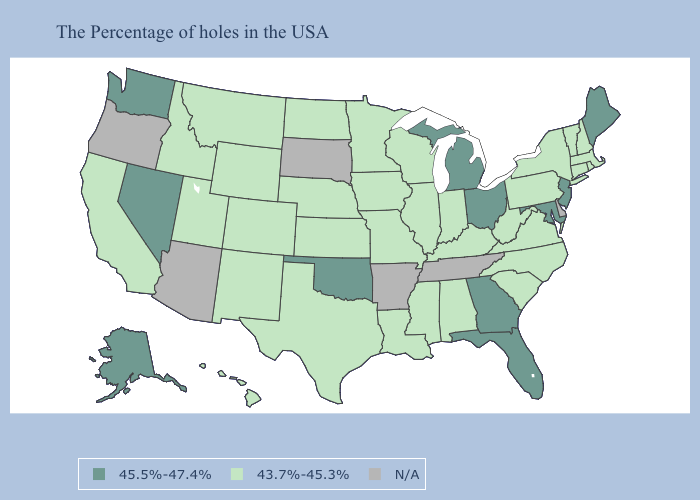Which states have the lowest value in the MidWest?
Quick response, please. Indiana, Wisconsin, Illinois, Missouri, Minnesota, Iowa, Kansas, Nebraska, North Dakota. Among the states that border North Carolina , does Virginia have the highest value?
Quick response, please. No. Name the states that have a value in the range 43.7%-45.3%?
Keep it brief. Massachusetts, Rhode Island, New Hampshire, Vermont, Connecticut, New York, Pennsylvania, Virginia, North Carolina, South Carolina, West Virginia, Kentucky, Indiana, Alabama, Wisconsin, Illinois, Mississippi, Louisiana, Missouri, Minnesota, Iowa, Kansas, Nebraska, Texas, North Dakota, Wyoming, Colorado, New Mexico, Utah, Montana, Idaho, California, Hawaii. Among the states that border Utah , does New Mexico have the highest value?
Keep it brief. No. Name the states that have a value in the range N/A?
Give a very brief answer. Delaware, Tennessee, Arkansas, South Dakota, Arizona, Oregon. Does the first symbol in the legend represent the smallest category?
Be succinct. No. Name the states that have a value in the range N/A?
Answer briefly. Delaware, Tennessee, Arkansas, South Dakota, Arizona, Oregon. Which states have the lowest value in the USA?
Concise answer only. Massachusetts, Rhode Island, New Hampshire, Vermont, Connecticut, New York, Pennsylvania, Virginia, North Carolina, South Carolina, West Virginia, Kentucky, Indiana, Alabama, Wisconsin, Illinois, Mississippi, Louisiana, Missouri, Minnesota, Iowa, Kansas, Nebraska, Texas, North Dakota, Wyoming, Colorado, New Mexico, Utah, Montana, Idaho, California, Hawaii. Name the states that have a value in the range N/A?
Give a very brief answer. Delaware, Tennessee, Arkansas, South Dakota, Arizona, Oregon. Name the states that have a value in the range 43.7%-45.3%?
Short answer required. Massachusetts, Rhode Island, New Hampshire, Vermont, Connecticut, New York, Pennsylvania, Virginia, North Carolina, South Carolina, West Virginia, Kentucky, Indiana, Alabama, Wisconsin, Illinois, Mississippi, Louisiana, Missouri, Minnesota, Iowa, Kansas, Nebraska, Texas, North Dakota, Wyoming, Colorado, New Mexico, Utah, Montana, Idaho, California, Hawaii. Name the states that have a value in the range N/A?
Write a very short answer. Delaware, Tennessee, Arkansas, South Dakota, Arizona, Oregon. What is the value of Kansas?
Quick response, please. 43.7%-45.3%. What is the value of Florida?
Keep it brief. 45.5%-47.4%. Name the states that have a value in the range 43.7%-45.3%?
Concise answer only. Massachusetts, Rhode Island, New Hampshire, Vermont, Connecticut, New York, Pennsylvania, Virginia, North Carolina, South Carolina, West Virginia, Kentucky, Indiana, Alabama, Wisconsin, Illinois, Mississippi, Louisiana, Missouri, Minnesota, Iowa, Kansas, Nebraska, Texas, North Dakota, Wyoming, Colorado, New Mexico, Utah, Montana, Idaho, California, Hawaii. 